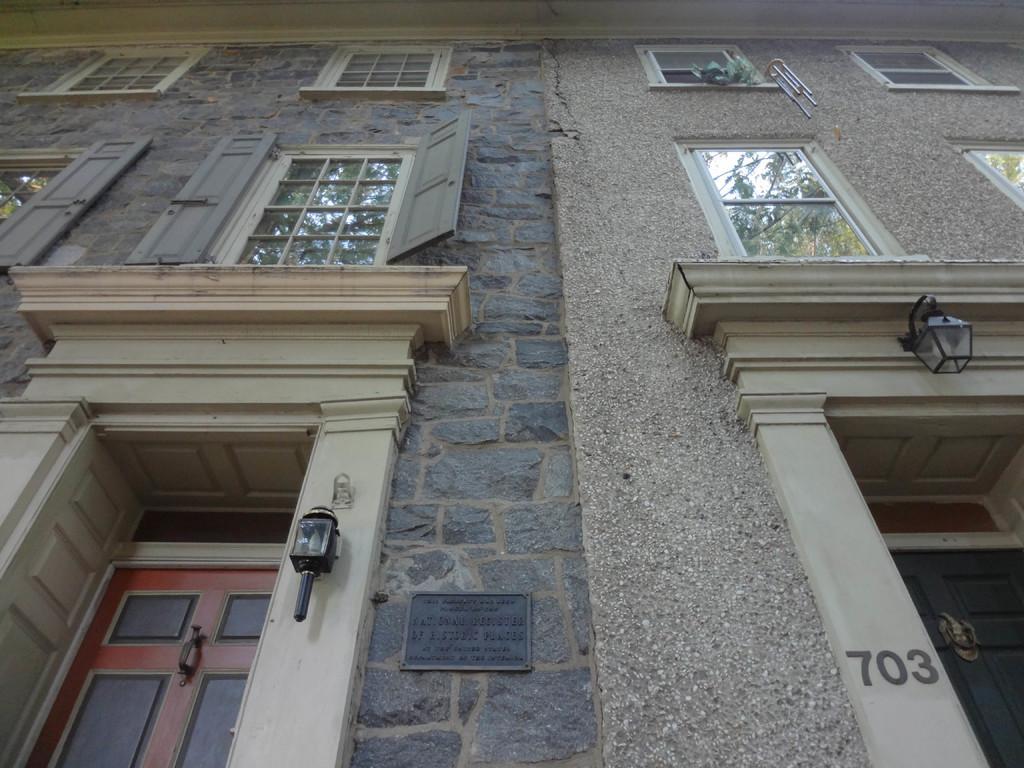In one or two sentences, can you explain what this image depicts? This is a building view image from the front side, in this image we can see doors, lamps and glass Windows. 